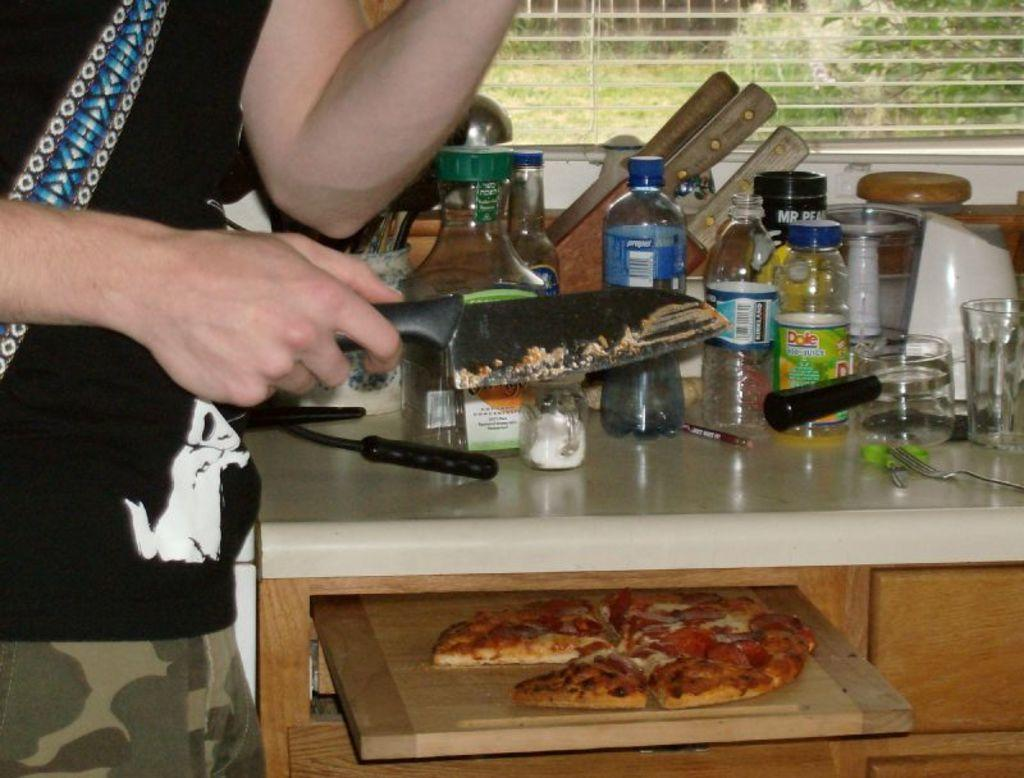<image>
Create a compact narrative representing the image presented. A messy countertop has a bottle with the name Dole on it. 